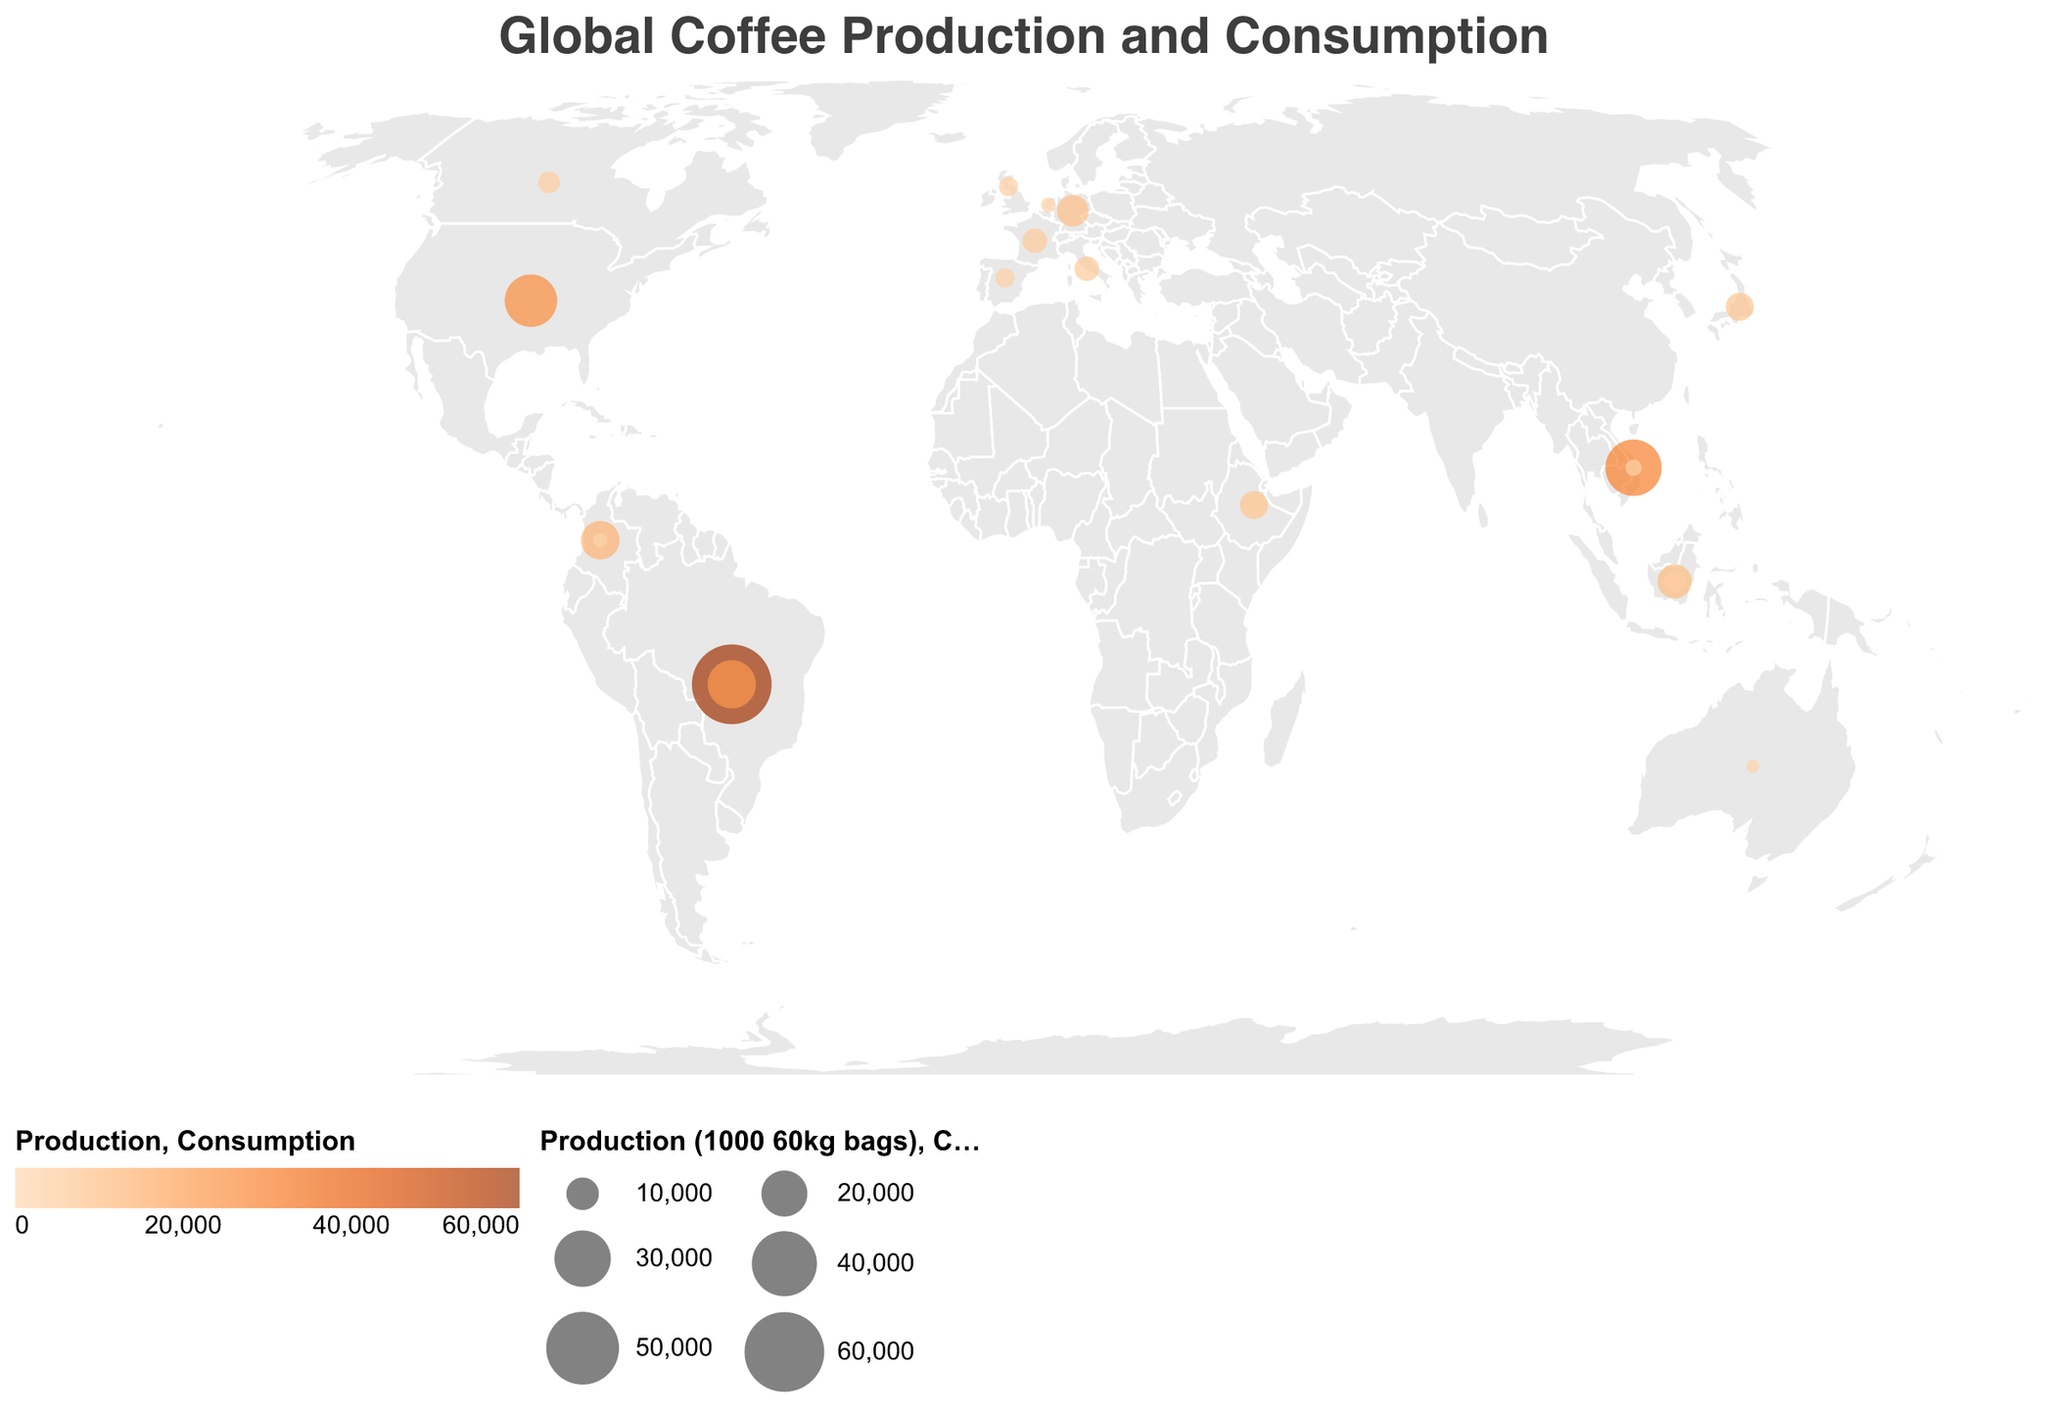What is the title of the figure? The title is located at the top of the figure and reads "Global Coffee Production and Consumption", providing an overview of the visualization.
Answer: Global Coffee Production and Consumption Which country has the highest coffee production? The country with the largest circle in the orange color scale represents the highest production. This circle is in Brazil.
Answer: Brazil How many countries are shown without coffee production data? The countries without production data do not have orange circles. By counting, we see 10 countries: United States, Germany, Italy, Japan, France, Canada, United Kingdom, Australia, Netherlands, and Spain.
Answer: 10 Which country imports the most coffee? The complexity requires looking for the countries with larger circles in blue, and the highest value will indicate the largest importer. The United States shows the largest blue circle.
Answer: United States Which country exports the most coffee? By comparing the size of the export figures, Brazil has the highest value with 35,000 60kg bags.
Answer: Brazil What is the range of coffee production shown in the figure? By looking at the smallest and largest orange circles, production ranges from 0 in several countries to 60,000 in Brazil.
Answer: 0 to 60,000 Sum the coffee consumption of France, Germany, and Italy. France consumes 5,800, Germany consumes 9,500, and Italy consumes 5,700. Adding them together, 5,800 + 9,500 + 5,700 = 21,000.
Answer: 21,000 Which country has a greater coffee consumption, Japan or Canada? By comparing the sizes of the blue circles for Japan and Canada, the circle for Japan is larger.
Answer: Japan Describe the areas of the world that are the major coffee growing regions. Major growing regions have larger orange circles, mainly in South America (Brazil, Colombia), Southeast Asia (Vietnam, Indonesia), and Africa (Ethiopia).
Answer: South America, Southeast Asia, Africa Compare the coffee consumption of the United States with the sum of consumption in the United Kingdom and Spain. The US consumes 26,000; the UK consumes 3,500 and Spain 3,500. Summing the UK and Spain, 3,500 + 3,500 = 7,000. The US consumption is greater than 7,000.
Answer: United States 